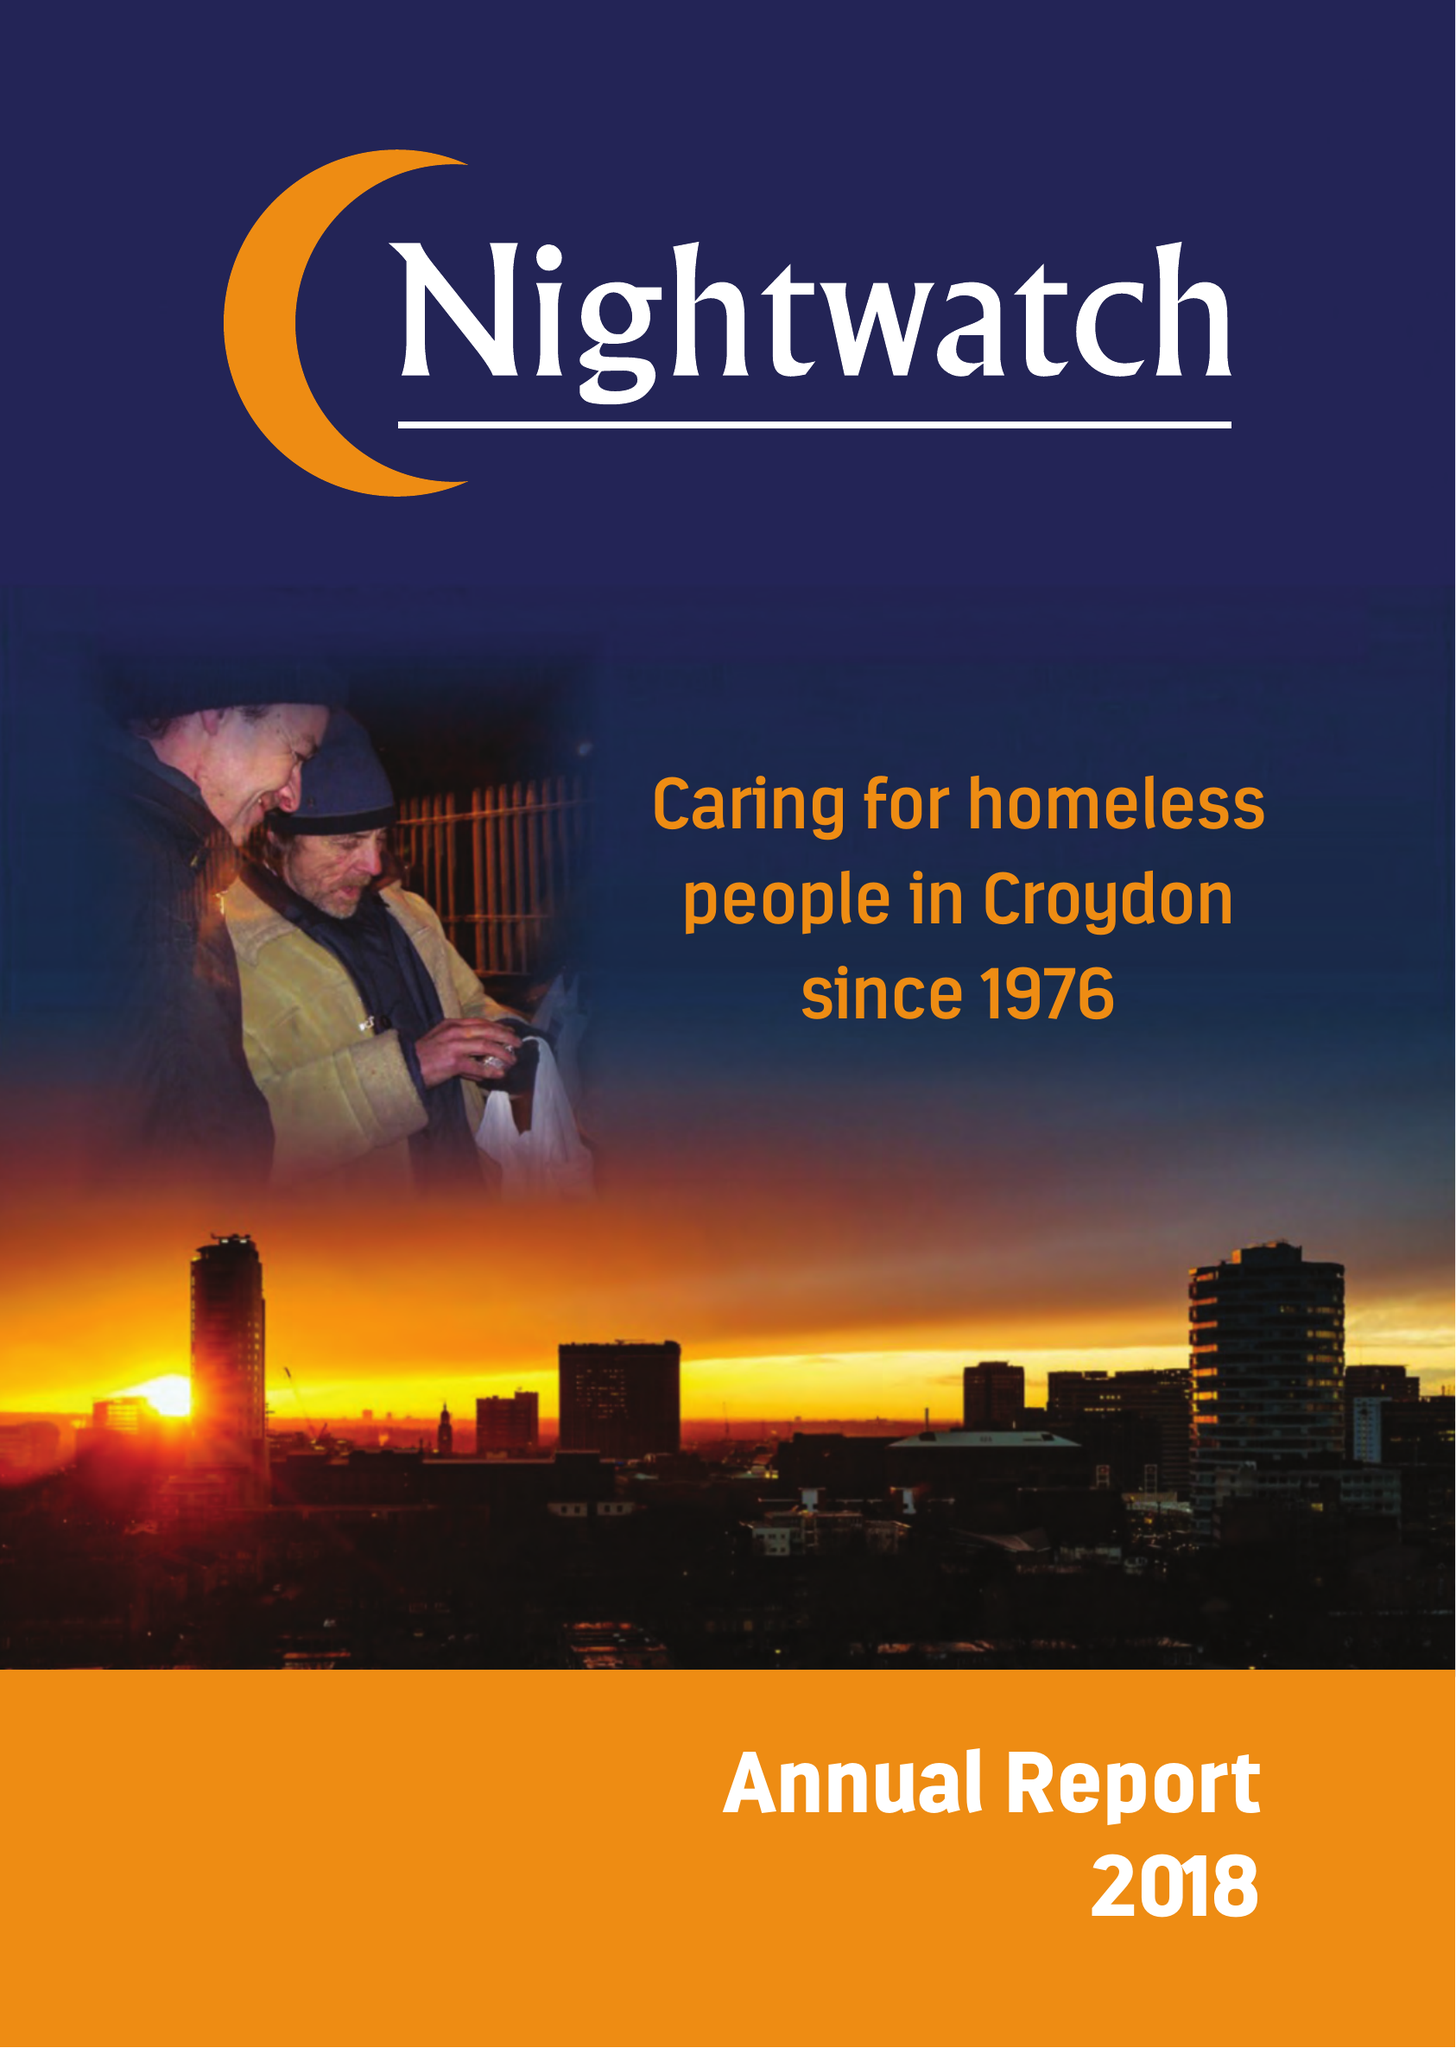What is the value for the charity_number?
Answer the question using a single word or phrase. 274925 